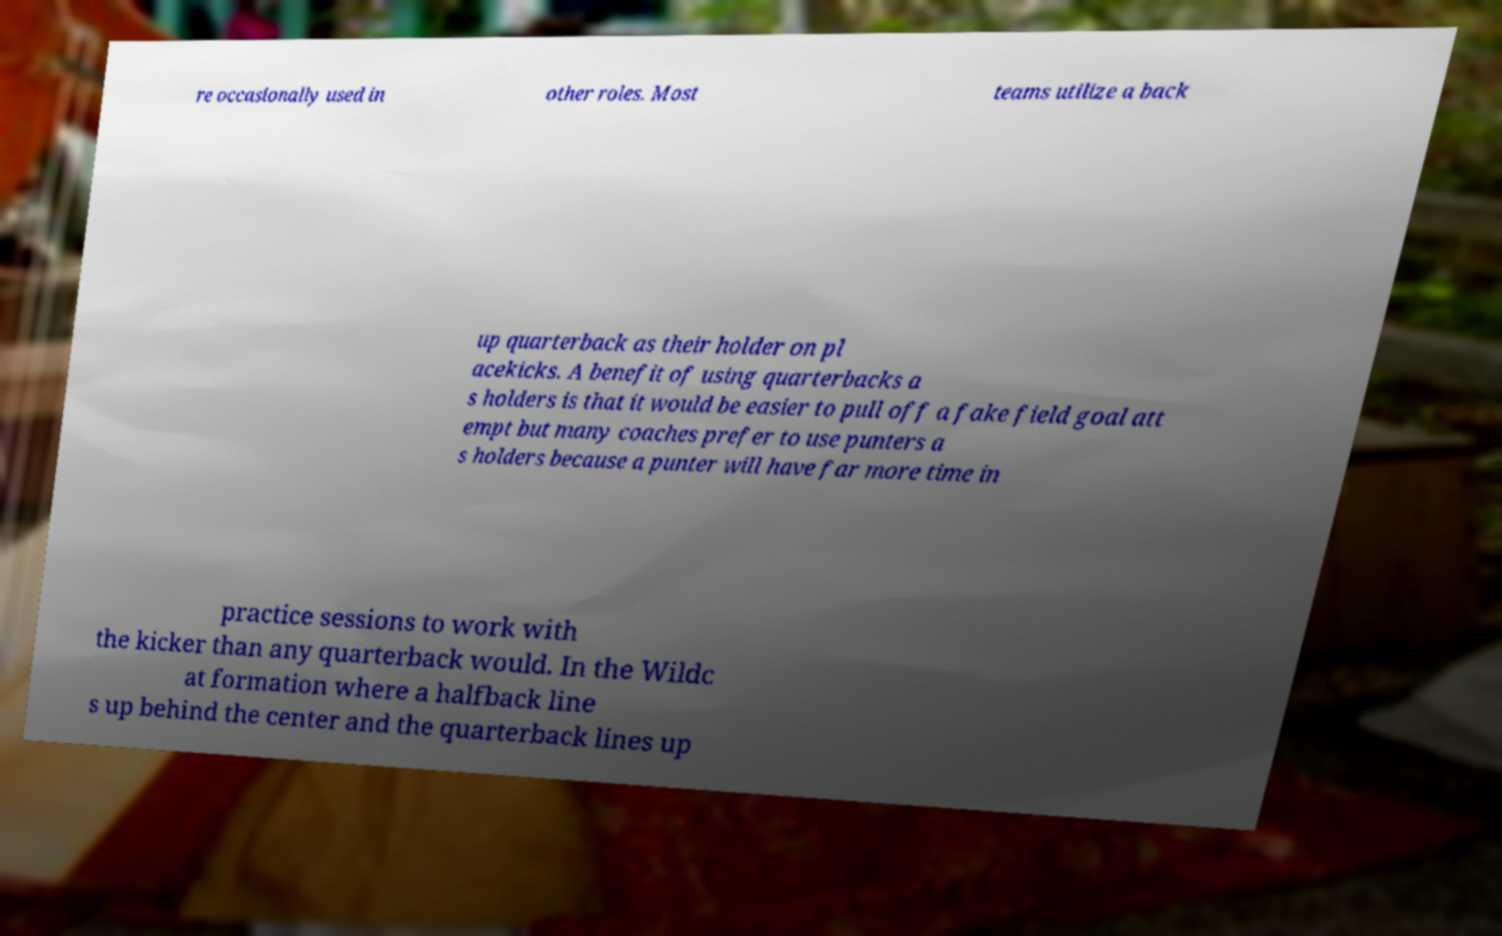Please identify and transcribe the text found in this image. re occasionally used in other roles. Most teams utilize a back up quarterback as their holder on pl acekicks. A benefit of using quarterbacks a s holders is that it would be easier to pull off a fake field goal att empt but many coaches prefer to use punters a s holders because a punter will have far more time in practice sessions to work with the kicker than any quarterback would. In the Wildc at formation where a halfback line s up behind the center and the quarterback lines up 